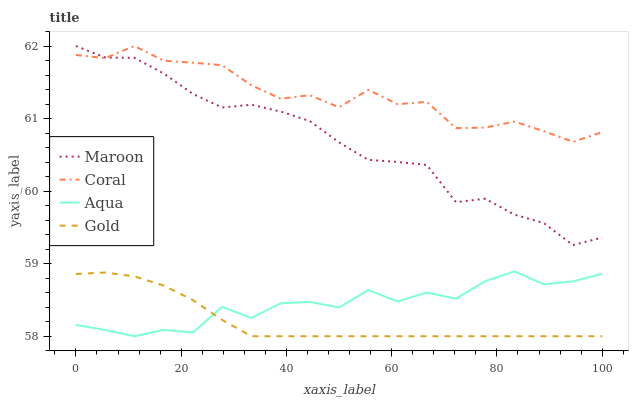Does Gold have the minimum area under the curve?
Answer yes or no. Yes. Does Coral have the maximum area under the curve?
Answer yes or no. Yes. Does Aqua have the minimum area under the curve?
Answer yes or no. No. Does Aqua have the maximum area under the curve?
Answer yes or no. No. Is Gold the smoothest?
Answer yes or no. Yes. Is Aqua the roughest?
Answer yes or no. Yes. Is Aqua the smoothest?
Answer yes or no. No. Is Gold the roughest?
Answer yes or no. No. Does Aqua have the lowest value?
Answer yes or no. Yes. Does Maroon have the lowest value?
Answer yes or no. No. Does Maroon have the highest value?
Answer yes or no. Yes. Does Aqua have the highest value?
Answer yes or no. No. Is Gold less than Coral?
Answer yes or no. Yes. Is Coral greater than Gold?
Answer yes or no. Yes. Does Gold intersect Aqua?
Answer yes or no. Yes. Is Gold less than Aqua?
Answer yes or no. No. Is Gold greater than Aqua?
Answer yes or no. No. Does Gold intersect Coral?
Answer yes or no. No. 